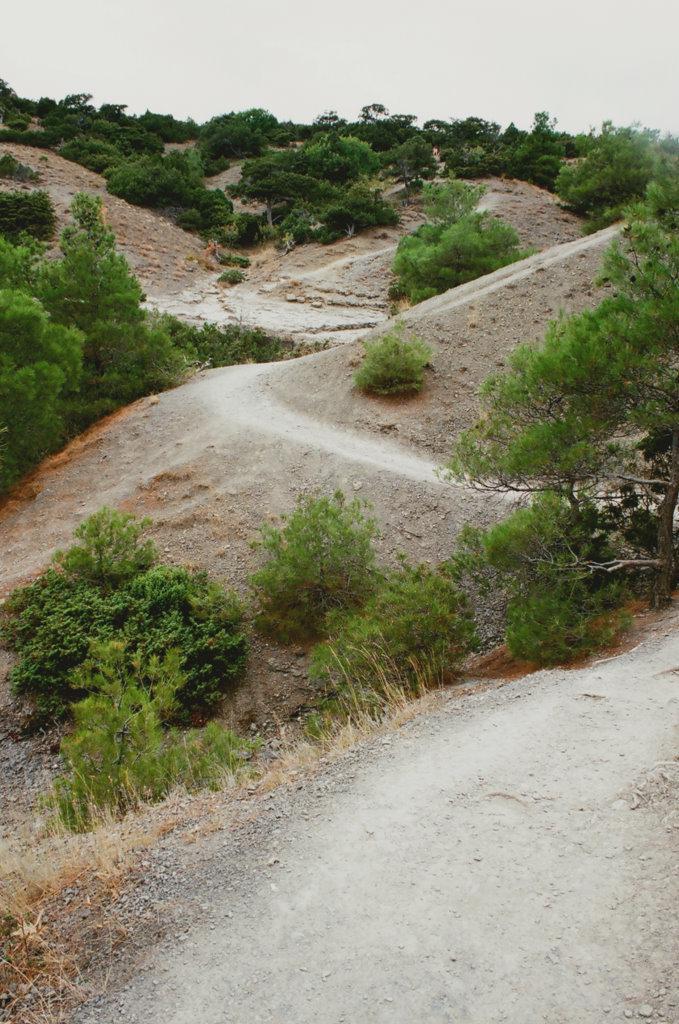Could you give a brief overview of what you see in this image? In this image there are plants and there's grass on the ground. 